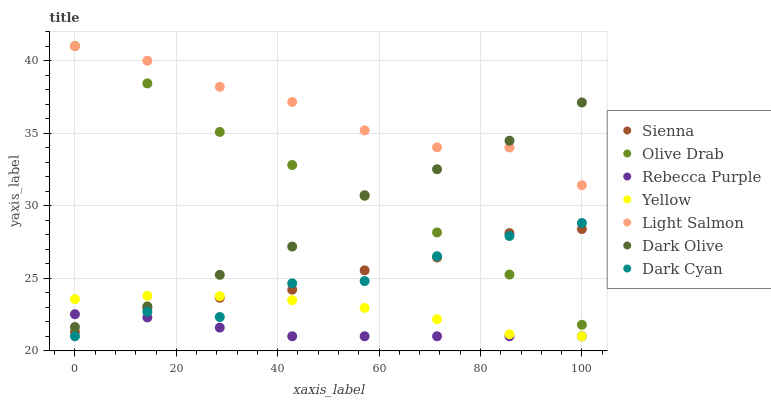Does Rebecca Purple have the minimum area under the curve?
Answer yes or no. Yes. Does Light Salmon have the maximum area under the curve?
Answer yes or no. Yes. Does Dark Olive have the minimum area under the curve?
Answer yes or no. No. Does Dark Olive have the maximum area under the curve?
Answer yes or no. No. Is Rebecca Purple the smoothest?
Answer yes or no. Yes. Is Dark Cyan the roughest?
Answer yes or no. Yes. Is Dark Olive the smoothest?
Answer yes or no. No. Is Dark Olive the roughest?
Answer yes or no. No. Does Yellow have the lowest value?
Answer yes or no. Yes. Does Dark Olive have the lowest value?
Answer yes or no. No. Does Olive Drab have the highest value?
Answer yes or no. Yes. Does Dark Olive have the highest value?
Answer yes or no. No. Is Dark Cyan less than Dark Olive?
Answer yes or no. Yes. Is Olive Drab greater than Rebecca Purple?
Answer yes or no. Yes. Does Olive Drab intersect Sienna?
Answer yes or no. Yes. Is Olive Drab less than Sienna?
Answer yes or no. No. Is Olive Drab greater than Sienna?
Answer yes or no. No. Does Dark Cyan intersect Dark Olive?
Answer yes or no. No. 